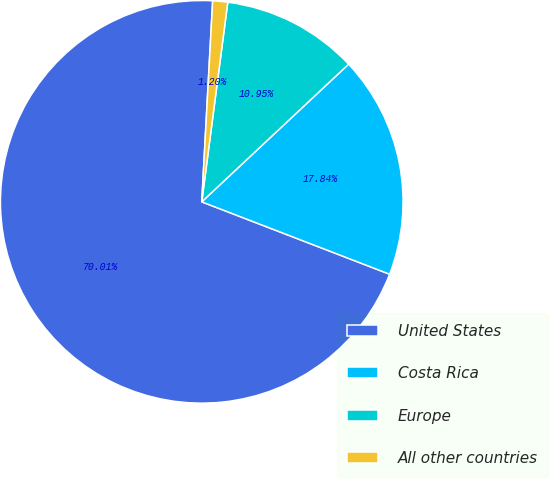Convert chart. <chart><loc_0><loc_0><loc_500><loc_500><pie_chart><fcel>United States<fcel>Costa Rica<fcel>Europe<fcel>All other countries<nl><fcel>70.01%<fcel>17.84%<fcel>10.95%<fcel>1.2%<nl></chart> 